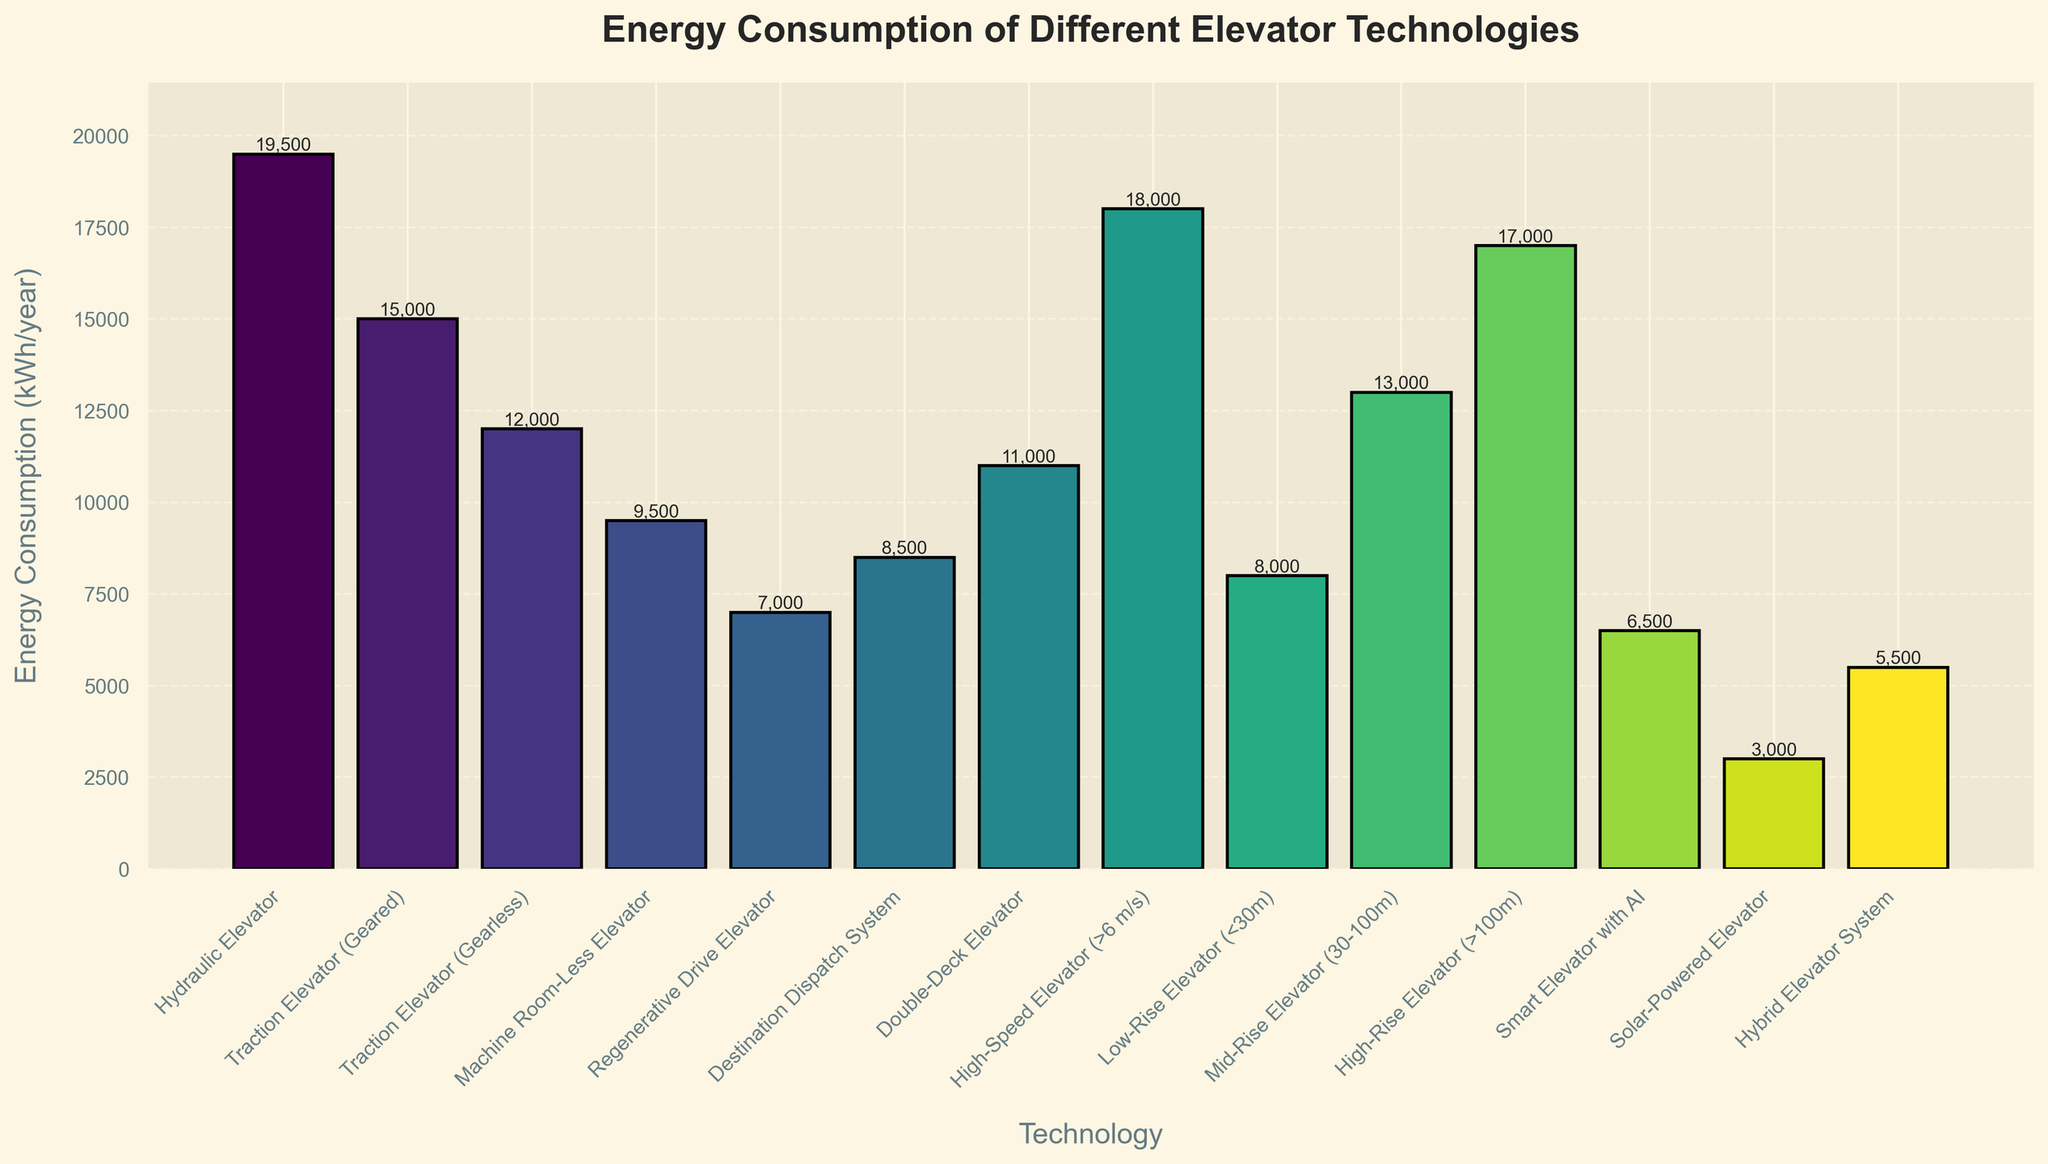Which elevator technology has the highest energy consumption? To find the highest energy consumption, look for the tallest bar in the chart. The hydraulic elevator has the tallest bar.
Answer: Hydraulic Elevator What is the difference in energy consumption between the Hydraulic Elevator and the Solar-Powered Elevator? To find the difference, subtract the energy consumption of the Solar-Powered Elevator from the Hydraulic Elevator. 19,500 kWh/year (Hydraulic Elevator) - 3,000 kWh/year (Solar-Powered Elevator) = 16,500 kWh/year.
Answer: 16,500 kWh/year Which elevator technology has the lowest energy consumption? To identify the lowest energy consumption, look for the shortest bar in the chart. The Solar-Powered Elevator has the shortest bar.
Answer: Solar-Powered Elevator Does the Regenerative Drive Elevator consume less energy than the High-Speed Elevator? Compare the heights of their bars. The Regenerative Drive Elevator (7,000 kWh/year) has a shorter bar than the High-Speed Elevator (18,000 kWh/year).
Answer: Yes What is the total energy consumption of the Machine Room-Less Elevator, the Smart Elevator with AI, and the Hybrid Elevator System? To find the total, add their energy consumptions: 9,500 kWh/year (Machine Room-Less Elevator) + 6,500 kWh/year (Smart Elevator with AI) + 5,500 kWh/year (Hybrid Elevator System) = 21,500 kWh/year.
Answer: 21,500 kWh/year Is the energy consumption of the Traction Elevator (Gearless) closer to that of the Double-Deck Elevator or the High-Rise Elevator (>100m)? Compare the energy consumptions: Traction Elevator (Gearless): 12,000 kWh/year Double-Deck Elevator: 11,000 kWh/year High-Rise Elevator: 17,000 kWh/year The difference with the Double-Deck Elevator is 1,000 kWh/year, and with the High-Rise Elevator is 5,000 kWh/year.
Answer: Double-Deck Elevator Rank the following elevators in ascending order of energy consumption: Hydraulic Elevator, Traction Elevator (Geared), Regenerative Drive Elevator, and Smart Elevator with AI. List their energy consumptions and sort in ascending order: Regenerative Drive Elevator (7,000 kWh/year) < Smart Elevator with AI (6,500 kWh/year) < Traction Elevator (Geared) (15,000 kWh/year) < Hydraulic Elevator (19,500 kWh/year).
Answer: Smart Elevator with AI, Regenerative Drive Elevator, Traction Elevator (Geared), Hydraulic Elevator What is the average energy consumption of all the elevator technologies listed? First, sum up all energy consumptions, then divide by the number of technologies: 3,000 + 5,500 + 6,500 + 7,000 + 8,000 + 8,500 + 9,500 + 11,000 + 12,000 + 13,000 + 15,000 + 17,000 + 18,000 + 19,500 = 144,500 kWh/year. There are 14 technologies, so: 144,500 / 14 ≈ 10,321 kWh/year.
Answer: 10,321 kWh/year 